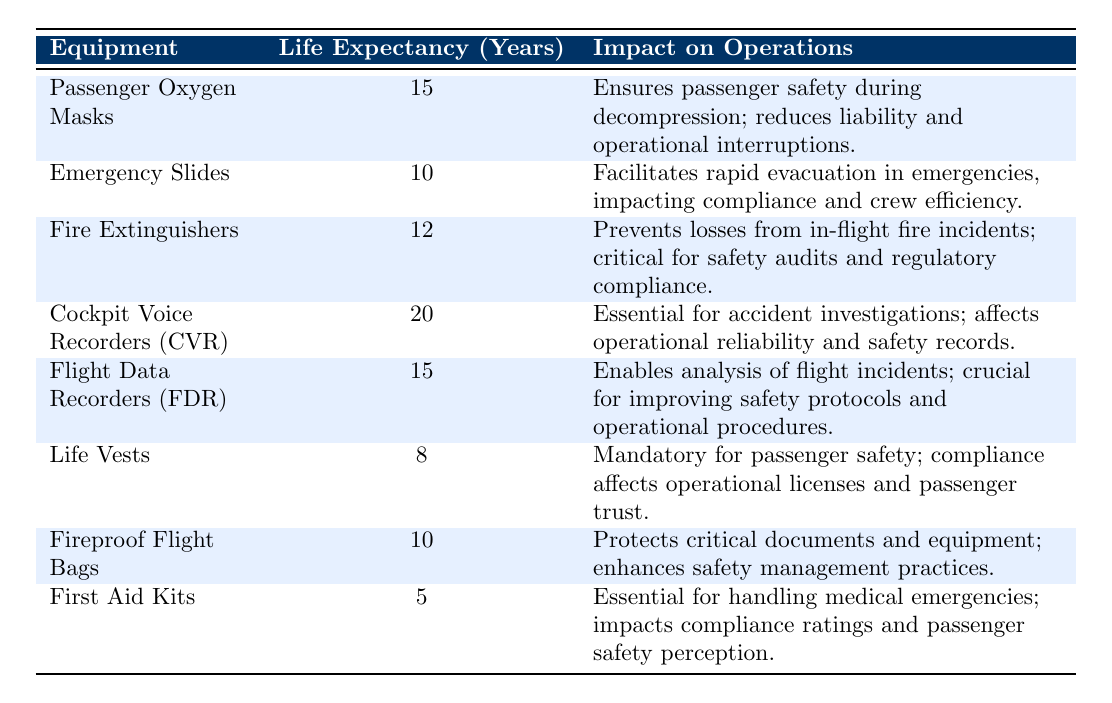What is the life expectancy of Emergency Slides? The life expectancy of Emergency Slides is stated directly in the table as 10 years.
Answer: 10 years Which equipment has the longest life expectancy? The table shows that Cockpit Voice Recorders (CVR) have the longest life expectancy at 20 years.
Answer: Cockpit Voice Recorders (CVR) How many pieces of equipment have a life expectancy of 15 years? There are two pieces of equipment listed with a life expectancy of 15 years: Passenger Oxygen Masks and Flight Data Recorders (FDR).
Answer: 2 What is the average life expectancy of Fire Extinguishers and Emergency Slides? The life expectancy of Fire Extinguishers is 12 years and Emergency Slides is 10 years. The average is (12 + 10) / 2 = 11 years.
Answer: 11 years Do First Aid Kits have a longer life expectancy than Life Vests? The life expectancy of First Aid Kits is 5 years, while Life Vests have a life expectancy of 8 years. Since 5 is less than 8, the statement is false.
Answer: No What is the total life expectancy of all the listed aviation safety equipment? To find the total, sum up all the life expectancies: 15 + 10 + 12 + 20 + 15 + 8 + 10 + 5 = 100 years.
Answer: 100 years Is the impact of Fire Extinguishers on operations related to preventing losses from fire incidents? Yes, according to the table, the impact of Fire Extinguishers is specifically noted as preventing losses from in-flight fire incidents.
Answer: Yes What would be the consequence of not having Life Vests according to the table? The table states that Life Vests are mandatory for passenger safety, and non-compliance affects operational licenses and passenger trust. Thus, not having them would lead to legal and trust issues.
Answer: Operational license issues and loss of trust 